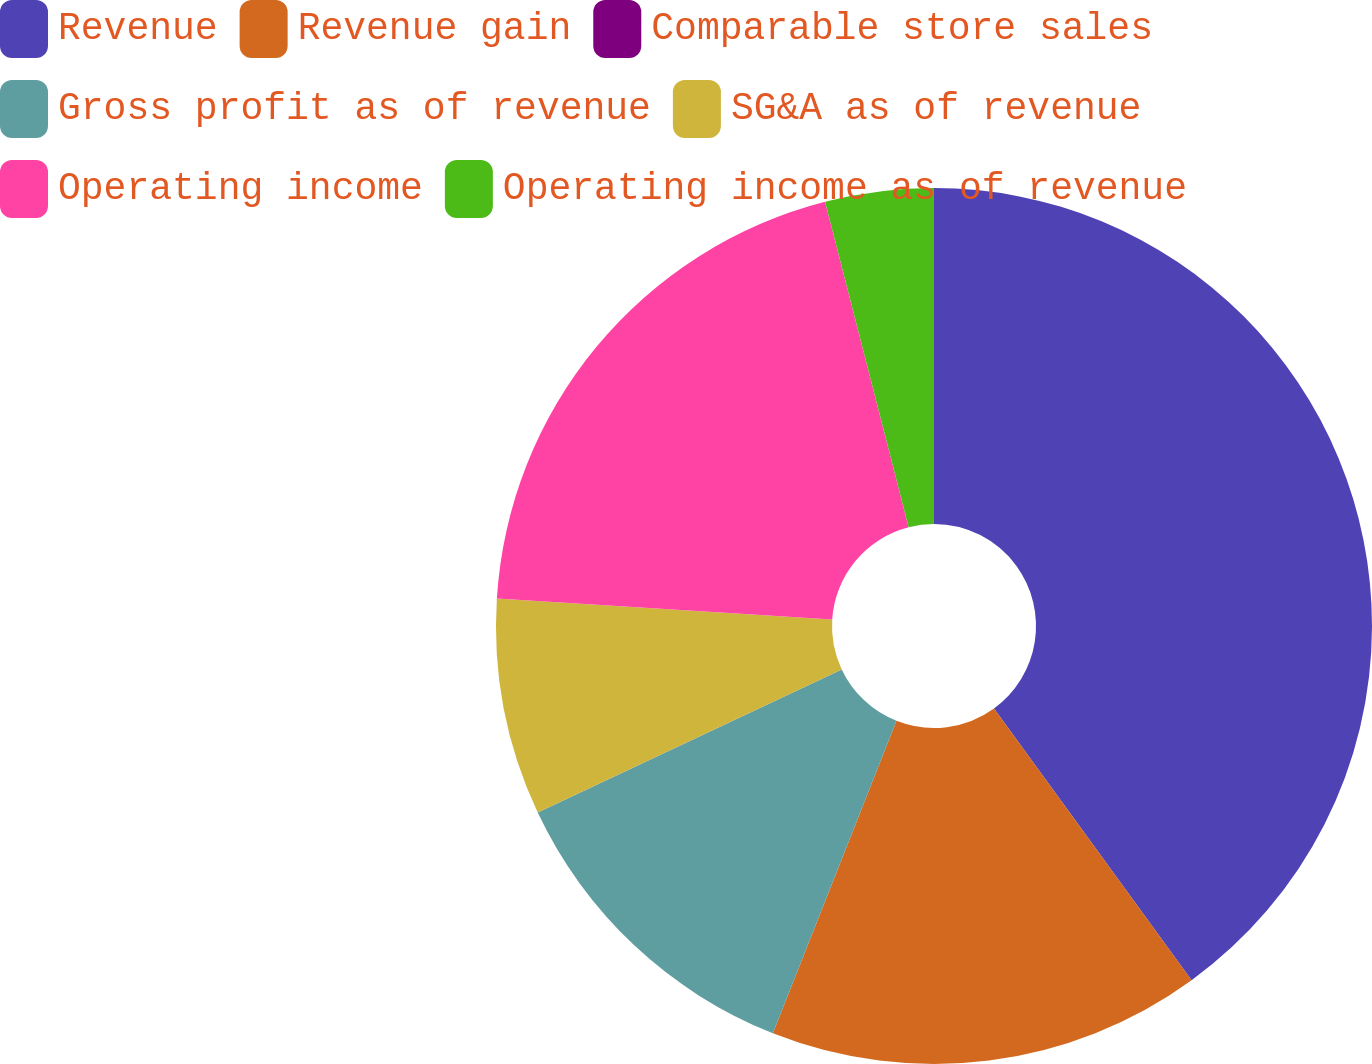<chart> <loc_0><loc_0><loc_500><loc_500><pie_chart><fcel>Revenue<fcel>Revenue gain<fcel>Comparable store sales<fcel>Gross profit as of revenue<fcel>SG&A as of revenue<fcel>Operating income<fcel>Operating income as of revenue<nl><fcel>39.99%<fcel>16.0%<fcel>0.0%<fcel>12.0%<fcel>8.0%<fcel>20.0%<fcel>4.0%<nl></chart> 